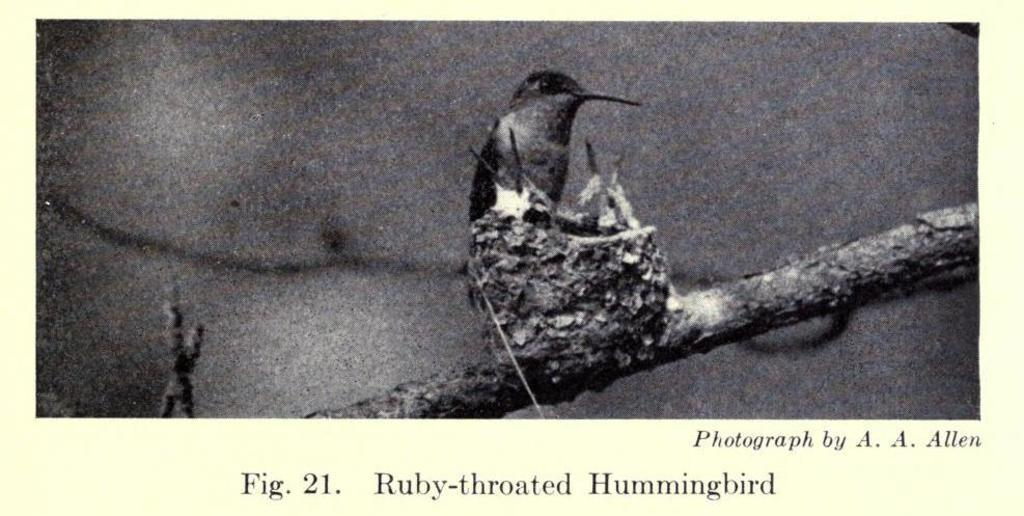What is depicted on the paper in the image? There is an image of a bird on the paper. Where is the bird located in the image? The bird is on a branch. What else can be seen on the paper besides the bird? There is writing on the paper. What type of dog can be seen playing with the border in the image? There is no dog or border present in the image; it features an image of a bird on a branch with writing on the paper. 